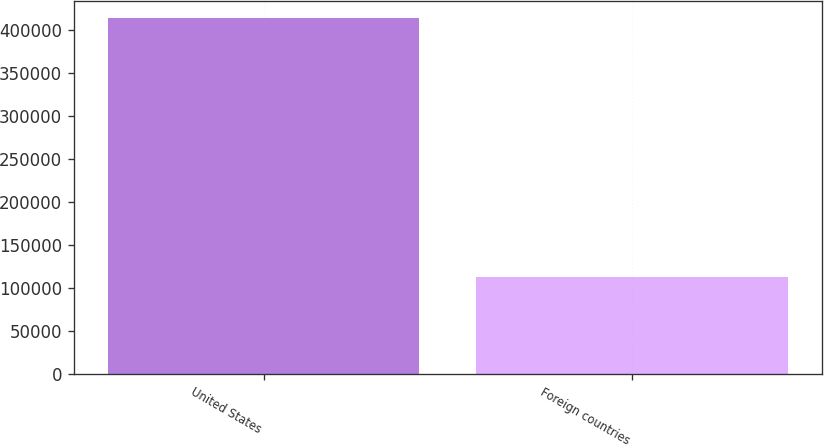Convert chart. <chart><loc_0><loc_0><loc_500><loc_500><bar_chart><fcel>United States<fcel>Foreign countries<nl><fcel>413499<fcel>112871<nl></chart> 